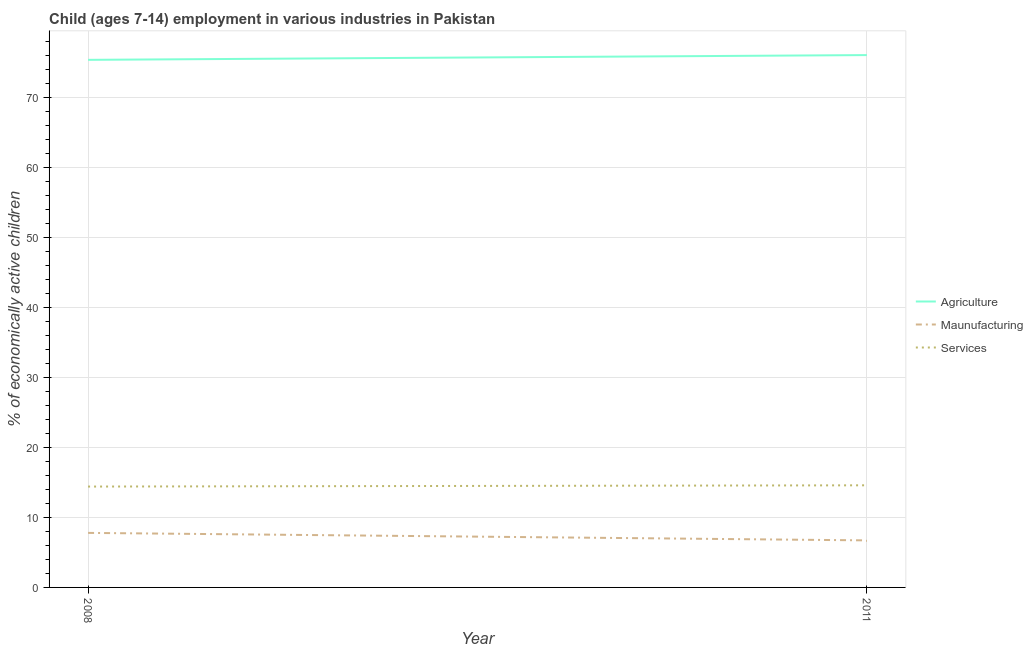How many different coloured lines are there?
Provide a short and direct response. 3. What is the percentage of economically active children in services in 2011?
Your answer should be compact. 14.59. Across all years, what is the maximum percentage of economically active children in agriculture?
Give a very brief answer. 76.05. Across all years, what is the minimum percentage of economically active children in manufacturing?
Keep it short and to the point. 6.72. In which year was the percentage of economically active children in manufacturing minimum?
Keep it short and to the point. 2011. What is the total percentage of economically active children in services in the graph?
Keep it short and to the point. 29. What is the difference between the percentage of economically active children in agriculture in 2008 and that in 2011?
Provide a short and direct response. -0.68. What is the difference between the percentage of economically active children in agriculture in 2008 and the percentage of economically active children in manufacturing in 2011?
Provide a short and direct response. 68.65. What is the average percentage of economically active children in agriculture per year?
Offer a terse response. 75.71. In the year 2008, what is the difference between the percentage of economically active children in manufacturing and percentage of economically active children in services?
Provide a succinct answer. -6.62. What is the ratio of the percentage of economically active children in manufacturing in 2008 to that in 2011?
Make the answer very short. 1.16. In how many years, is the percentage of economically active children in services greater than the average percentage of economically active children in services taken over all years?
Give a very brief answer. 1. Is it the case that in every year, the sum of the percentage of economically active children in agriculture and percentage of economically active children in manufacturing is greater than the percentage of economically active children in services?
Your response must be concise. Yes. Does the percentage of economically active children in manufacturing monotonically increase over the years?
Give a very brief answer. No. Is the percentage of economically active children in manufacturing strictly greater than the percentage of economically active children in services over the years?
Your response must be concise. No. Is the percentage of economically active children in services strictly less than the percentage of economically active children in manufacturing over the years?
Make the answer very short. No. How many years are there in the graph?
Your response must be concise. 2. What is the difference between two consecutive major ticks on the Y-axis?
Provide a succinct answer. 10. How many legend labels are there?
Offer a terse response. 3. How are the legend labels stacked?
Make the answer very short. Vertical. What is the title of the graph?
Your answer should be compact. Child (ages 7-14) employment in various industries in Pakistan. What is the label or title of the Y-axis?
Your answer should be compact. % of economically active children. What is the % of economically active children in Agriculture in 2008?
Keep it short and to the point. 75.37. What is the % of economically active children in Maunufacturing in 2008?
Make the answer very short. 7.79. What is the % of economically active children of Services in 2008?
Provide a short and direct response. 14.41. What is the % of economically active children in Agriculture in 2011?
Your answer should be very brief. 76.05. What is the % of economically active children in Maunufacturing in 2011?
Provide a succinct answer. 6.72. What is the % of economically active children of Services in 2011?
Offer a terse response. 14.59. Across all years, what is the maximum % of economically active children in Agriculture?
Provide a succinct answer. 76.05. Across all years, what is the maximum % of economically active children in Maunufacturing?
Your answer should be compact. 7.79. Across all years, what is the maximum % of economically active children in Services?
Offer a very short reply. 14.59. Across all years, what is the minimum % of economically active children in Agriculture?
Offer a very short reply. 75.37. Across all years, what is the minimum % of economically active children of Maunufacturing?
Your answer should be compact. 6.72. Across all years, what is the minimum % of economically active children of Services?
Keep it short and to the point. 14.41. What is the total % of economically active children in Agriculture in the graph?
Your answer should be very brief. 151.42. What is the total % of economically active children of Maunufacturing in the graph?
Provide a short and direct response. 14.51. What is the total % of economically active children in Services in the graph?
Your answer should be compact. 29. What is the difference between the % of economically active children of Agriculture in 2008 and that in 2011?
Provide a succinct answer. -0.68. What is the difference between the % of economically active children of Maunufacturing in 2008 and that in 2011?
Provide a short and direct response. 1.07. What is the difference between the % of economically active children in Services in 2008 and that in 2011?
Make the answer very short. -0.18. What is the difference between the % of economically active children in Agriculture in 2008 and the % of economically active children in Maunufacturing in 2011?
Provide a succinct answer. 68.65. What is the difference between the % of economically active children in Agriculture in 2008 and the % of economically active children in Services in 2011?
Your answer should be very brief. 60.78. What is the average % of economically active children in Agriculture per year?
Offer a terse response. 75.71. What is the average % of economically active children in Maunufacturing per year?
Offer a very short reply. 7.25. What is the average % of economically active children of Services per year?
Your response must be concise. 14.5. In the year 2008, what is the difference between the % of economically active children in Agriculture and % of economically active children in Maunufacturing?
Give a very brief answer. 67.58. In the year 2008, what is the difference between the % of economically active children of Agriculture and % of economically active children of Services?
Ensure brevity in your answer.  60.96. In the year 2008, what is the difference between the % of economically active children of Maunufacturing and % of economically active children of Services?
Make the answer very short. -6.62. In the year 2011, what is the difference between the % of economically active children of Agriculture and % of economically active children of Maunufacturing?
Give a very brief answer. 69.33. In the year 2011, what is the difference between the % of economically active children of Agriculture and % of economically active children of Services?
Your answer should be very brief. 61.46. In the year 2011, what is the difference between the % of economically active children in Maunufacturing and % of economically active children in Services?
Keep it short and to the point. -7.87. What is the ratio of the % of economically active children of Maunufacturing in 2008 to that in 2011?
Ensure brevity in your answer.  1.16. What is the ratio of the % of economically active children in Services in 2008 to that in 2011?
Provide a succinct answer. 0.99. What is the difference between the highest and the second highest % of economically active children in Agriculture?
Keep it short and to the point. 0.68. What is the difference between the highest and the second highest % of economically active children of Maunufacturing?
Provide a succinct answer. 1.07. What is the difference between the highest and the second highest % of economically active children in Services?
Offer a very short reply. 0.18. What is the difference between the highest and the lowest % of economically active children of Agriculture?
Your answer should be compact. 0.68. What is the difference between the highest and the lowest % of economically active children in Maunufacturing?
Provide a short and direct response. 1.07. What is the difference between the highest and the lowest % of economically active children in Services?
Your answer should be very brief. 0.18. 